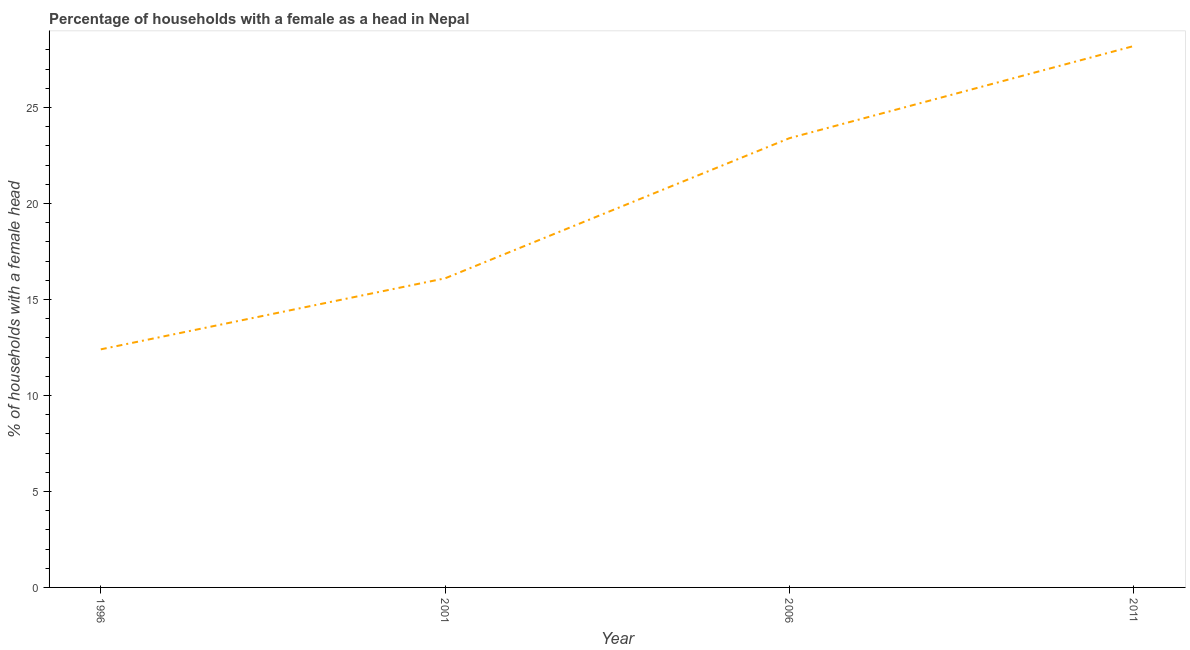What is the number of female supervised households in 2006?
Provide a short and direct response. 23.4. Across all years, what is the maximum number of female supervised households?
Make the answer very short. 28.2. In which year was the number of female supervised households maximum?
Provide a short and direct response. 2011. In which year was the number of female supervised households minimum?
Offer a very short reply. 1996. What is the sum of the number of female supervised households?
Provide a short and direct response. 80.1. What is the difference between the number of female supervised households in 2006 and 2011?
Your answer should be compact. -4.8. What is the average number of female supervised households per year?
Keep it short and to the point. 20.02. What is the median number of female supervised households?
Make the answer very short. 19.75. In how many years, is the number of female supervised households greater than 6 %?
Provide a succinct answer. 4. What is the ratio of the number of female supervised households in 2001 to that in 2006?
Your answer should be compact. 0.69. Is the difference between the number of female supervised households in 2006 and 2011 greater than the difference between any two years?
Your answer should be very brief. No. What is the difference between the highest and the second highest number of female supervised households?
Make the answer very short. 4.8. Is the sum of the number of female supervised households in 2006 and 2011 greater than the maximum number of female supervised households across all years?
Give a very brief answer. Yes. What is the difference between the highest and the lowest number of female supervised households?
Provide a succinct answer. 15.8. In how many years, is the number of female supervised households greater than the average number of female supervised households taken over all years?
Make the answer very short. 2. Does the number of female supervised households monotonically increase over the years?
Offer a terse response. Yes. How many lines are there?
Give a very brief answer. 1. How many years are there in the graph?
Make the answer very short. 4. What is the difference between two consecutive major ticks on the Y-axis?
Offer a terse response. 5. What is the title of the graph?
Your answer should be very brief. Percentage of households with a female as a head in Nepal. What is the label or title of the X-axis?
Provide a succinct answer. Year. What is the label or title of the Y-axis?
Make the answer very short. % of households with a female head. What is the % of households with a female head in 2006?
Give a very brief answer. 23.4. What is the % of households with a female head in 2011?
Your answer should be compact. 28.2. What is the difference between the % of households with a female head in 1996 and 2001?
Offer a very short reply. -3.7. What is the difference between the % of households with a female head in 1996 and 2006?
Provide a succinct answer. -11. What is the difference between the % of households with a female head in 1996 and 2011?
Your answer should be compact. -15.8. What is the difference between the % of households with a female head in 2001 and 2011?
Give a very brief answer. -12.1. What is the difference between the % of households with a female head in 2006 and 2011?
Your response must be concise. -4.8. What is the ratio of the % of households with a female head in 1996 to that in 2001?
Ensure brevity in your answer.  0.77. What is the ratio of the % of households with a female head in 1996 to that in 2006?
Your answer should be compact. 0.53. What is the ratio of the % of households with a female head in 1996 to that in 2011?
Provide a short and direct response. 0.44. What is the ratio of the % of households with a female head in 2001 to that in 2006?
Provide a succinct answer. 0.69. What is the ratio of the % of households with a female head in 2001 to that in 2011?
Give a very brief answer. 0.57. What is the ratio of the % of households with a female head in 2006 to that in 2011?
Provide a succinct answer. 0.83. 